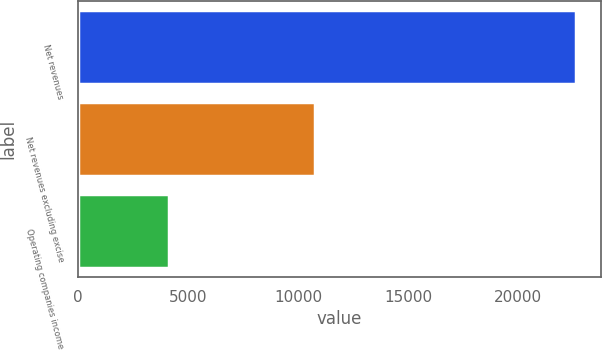Convert chart to OTSL. <chart><loc_0><loc_0><loc_500><loc_500><bar_chart><fcel>Net revenues<fcel>Net revenues excluding excise<fcel>Operating companies income<nl><fcel>22635<fcel>10790<fcel>4149<nl></chart> 